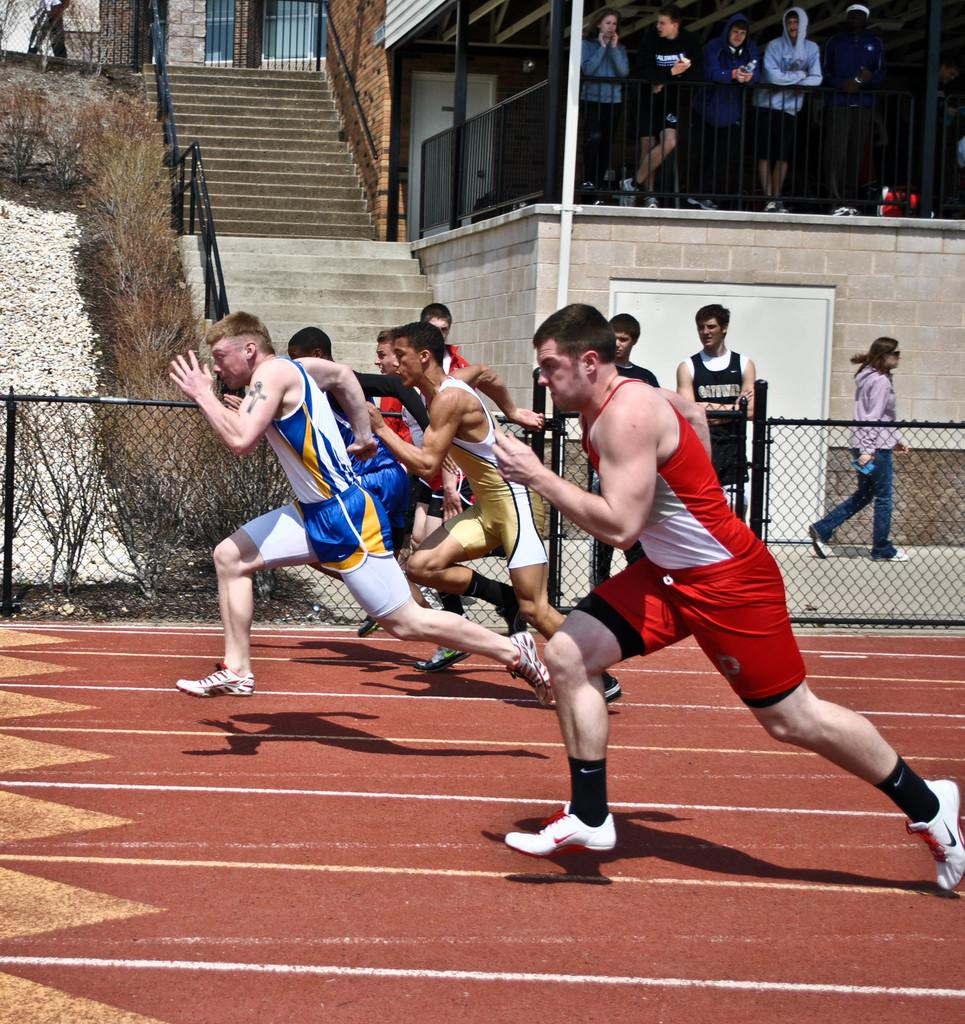What are the people in the middle of the image doing? The people in the middle of the image are running. What structure is visible at the top of the image? There is a staircase at the top of the image. What are the people on the right side of the image doing? The people on the right side of the image are standing and observing the game. Can you tell me how much salt is on the plate in the image? There is no plate or salt present in the image. What are the people doing with their hands in the image? The provided facts do not mention anything about people using their hands in the image. 